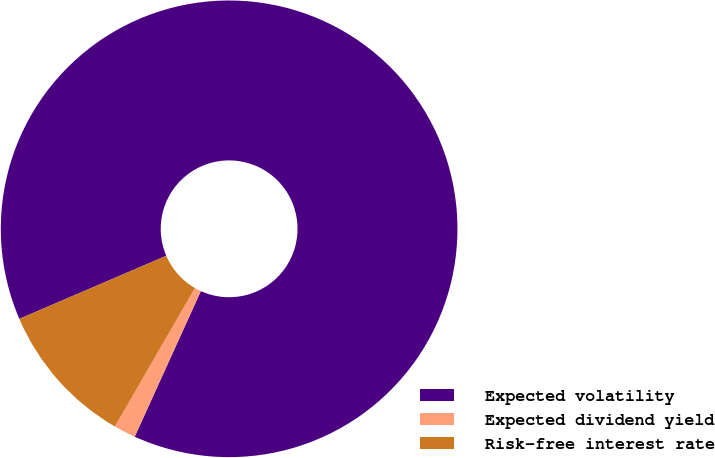Convert chart to OTSL. <chart><loc_0><loc_0><loc_500><loc_500><pie_chart><fcel>Expected volatility<fcel>Expected dividend yield<fcel>Risk-free interest rate<nl><fcel>88.24%<fcel>1.55%<fcel>10.21%<nl></chart> 